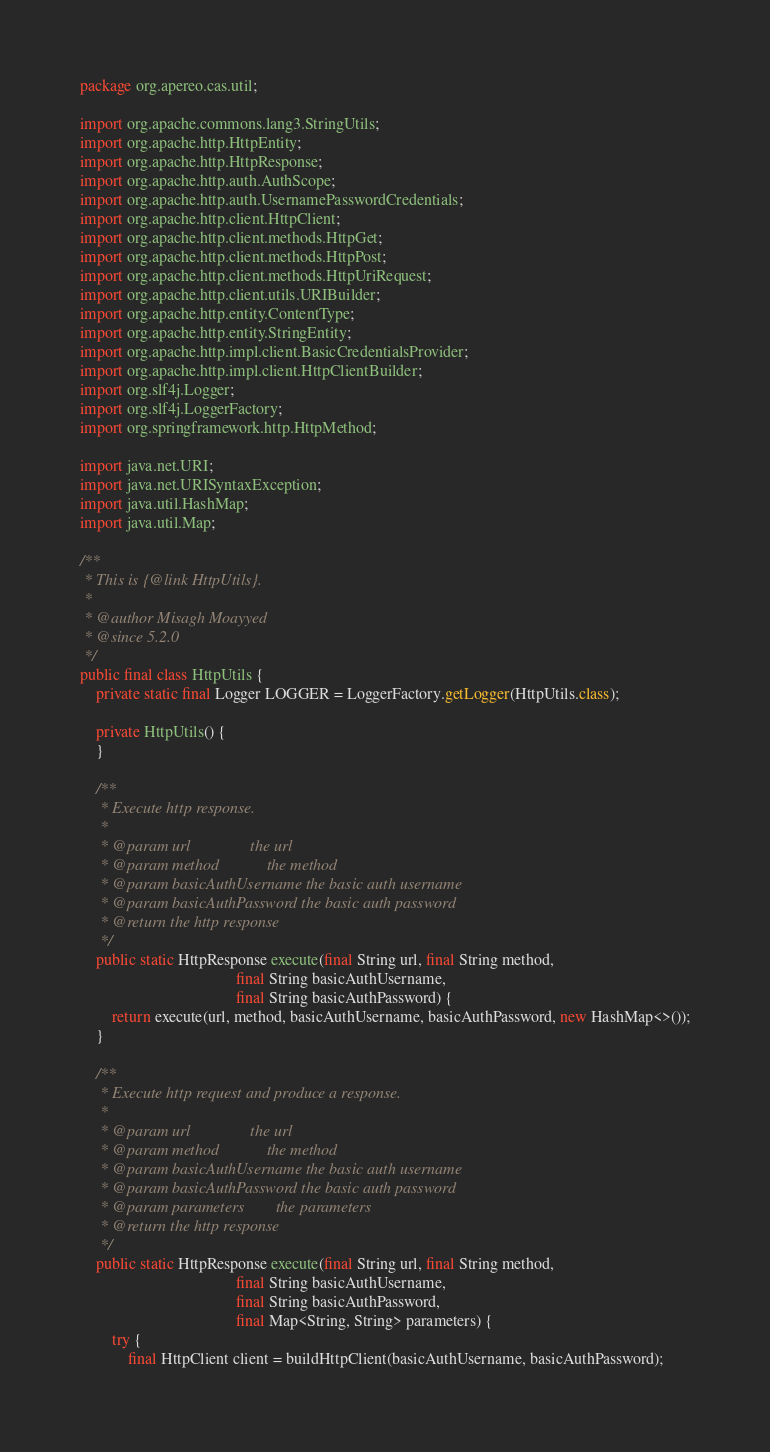Convert code to text. <code><loc_0><loc_0><loc_500><loc_500><_Java_>package org.apereo.cas.util;

import org.apache.commons.lang3.StringUtils;
import org.apache.http.HttpEntity;
import org.apache.http.HttpResponse;
import org.apache.http.auth.AuthScope;
import org.apache.http.auth.UsernamePasswordCredentials;
import org.apache.http.client.HttpClient;
import org.apache.http.client.methods.HttpGet;
import org.apache.http.client.methods.HttpPost;
import org.apache.http.client.methods.HttpUriRequest;
import org.apache.http.client.utils.URIBuilder;
import org.apache.http.entity.ContentType;
import org.apache.http.entity.StringEntity;
import org.apache.http.impl.client.BasicCredentialsProvider;
import org.apache.http.impl.client.HttpClientBuilder;
import org.slf4j.Logger;
import org.slf4j.LoggerFactory;
import org.springframework.http.HttpMethod;

import java.net.URI;
import java.net.URISyntaxException;
import java.util.HashMap;
import java.util.Map;

/**
 * This is {@link HttpUtils}.
 *
 * @author Misagh Moayyed
 * @since 5.2.0
 */
public final class HttpUtils {
    private static final Logger LOGGER = LoggerFactory.getLogger(HttpUtils.class);

    private HttpUtils() {
    }

    /**
     * Execute http response.
     *
     * @param url               the url
     * @param method            the method
     * @param basicAuthUsername the basic auth username
     * @param basicAuthPassword the basic auth password
     * @return the http response
     */
    public static HttpResponse execute(final String url, final String method,
                                       final String basicAuthUsername,
                                       final String basicAuthPassword) {
        return execute(url, method, basicAuthUsername, basicAuthPassword, new HashMap<>());
    }

    /**
     * Execute http request and produce a response.
     *
     * @param url               the url
     * @param method            the method
     * @param basicAuthUsername the basic auth username
     * @param basicAuthPassword the basic auth password
     * @param parameters        the parameters
     * @return the http response
     */
    public static HttpResponse execute(final String url, final String method,
                                       final String basicAuthUsername,
                                       final String basicAuthPassword,
                                       final Map<String, String> parameters) {
        try {
            final HttpClient client = buildHttpClient(basicAuthUsername, basicAuthPassword);</code> 